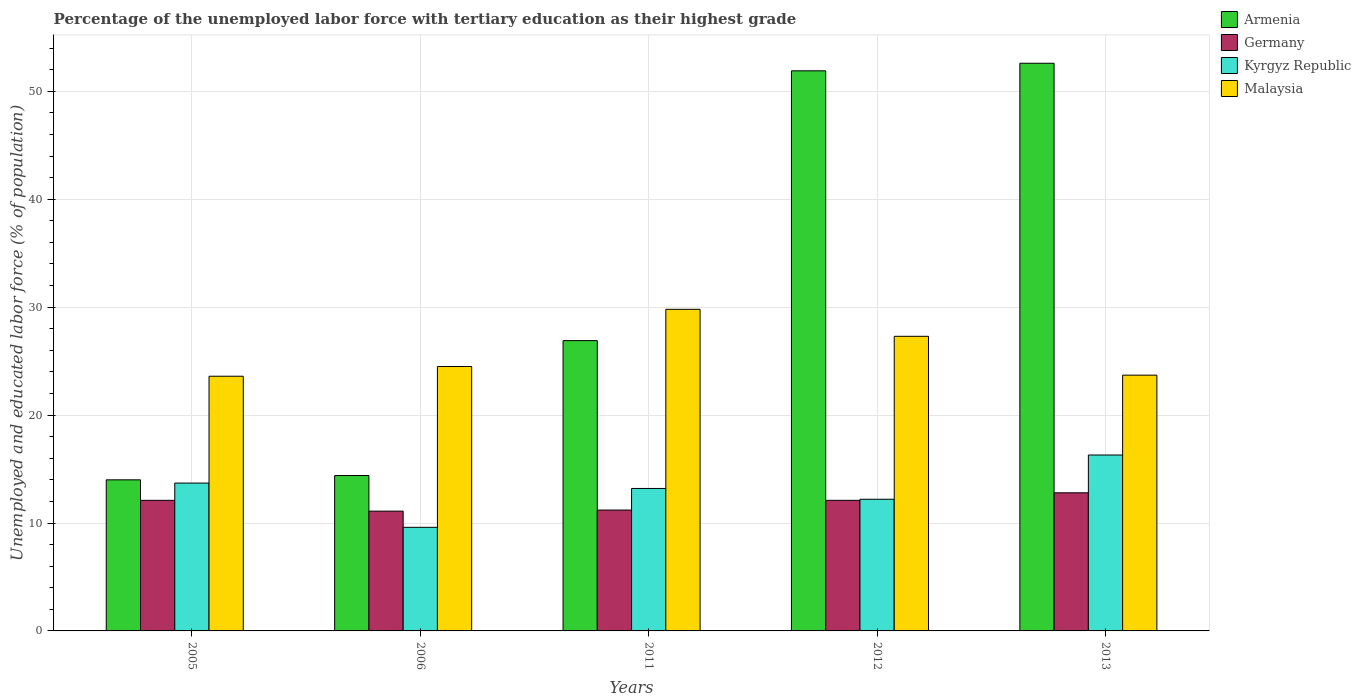How many different coloured bars are there?
Offer a terse response. 4. How many bars are there on the 4th tick from the left?
Offer a very short reply. 4. In how many cases, is the number of bars for a given year not equal to the number of legend labels?
Make the answer very short. 0. What is the percentage of the unemployed labor force with tertiary education in Malaysia in 2005?
Your answer should be very brief. 23.6. Across all years, what is the maximum percentage of the unemployed labor force with tertiary education in Armenia?
Your answer should be very brief. 52.6. Across all years, what is the minimum percentage of the unemployed labor force with tertiary education in Armenia?
Give a very brief answer. 14. In which year was the percentage of the unemployed labor force with tertiary education in Malaysia minimum?
Your answer should be very brief. 2005. What is the total percentage of the unemployed labor force with tertiary education in Malaysia in the graph?
Provide a succinct answer. 128.9. What is the difference between the percentage of the unemployed labor force with tertiary education in Armenia in 2011 and that in 2012?
Your response must be concise. -25. What is the difference between the percentage of the unemployed labor force with tertiary education in Germany in 2012 and the percentage of the unemployed labor force with tertiary education in Armenia in 2013?
Give a very brief answer. -40.5. What is the average percentage of the unemployed labor force with tertiary education in Germany per year?
Your answer should be very brief. 11.86. In the year 2011, what is the difference between the percentage of the unemployed labor force with tertiary education in Kyrgyz Republic and percentage of the unemployed labor force with tertiary education in Germany?
Your answer should be compact. 2. In how many years, is the percentage of the unemployed labor force with tertiary education in Kyrgyz Republic greater than 38 %?
Your answer should be compact. 0. What is the ratio of the percentage of the unemployed labor force with tertiary education in Kyrgyz Republic in 2005 to that in 2011?
Keep it short and to the point. 1.04. Is the percentage of the unemployed labor force with tertiary education in Armenia in 2012 less than that in 2013?
Your response must be concise. Yes. Is the difference between the percentage of the unemployed labor force with tertiary education in Kyrgyz Republic in 2006 and 2011 greater than the difference between the percentage of the unemployed labor force with tertiary education in Germany in 2006 and 2011?
Your response must be concise. No. What is the difference between the highest and the lowest percentage of the unemployed labor force with tertiary education in Malaysia?
Your answer should be very brief. 6.2. In how many years, is the percentage of the unemployed labor force with tertiary education in Germany greater than the average percentage of the unemployed labor force with tertiary education in Germany taken over all years?
Make the answer very short. 3. Is the sum of the percentage of the unemployed labor force with tertiary education in Kyrgyz Republic in 2011 and 2012 greater than the maximum percentage of the unemployed labor force with tertiary education in Armenia across all years?
Offer a terse response. No. Is it the case that in every year, the sum of the percentage of the unemployed labor force with tertiary education in Kyrgyz Republic and percentage of the unemployed labor force with tertiary education in Germany is greater than the sum of percentage of the unemployed labor force with tertiary education in Malaysia and percentage of the unemployed labor force with tertiary education in Armenia?
Offer a very short reply. No. What does the 2nd bar from the right in 2006 represents?
Ensure brevity in your answer.  Kyrgyz Republic. Is it the case that in every year, the sum of the percentage of the unemployed labor force with tertiary education in Kyrgyz Republic and percentage of the unemployed labor force with tertiary education in Germany is greater than the percentage of the unemployed labor force with tertiary education in Malaysia?
Give a very brief answer. No. How many bars are there?
Your answer should be very brief. 20. Are all the bars in the graph horizontal?
Your answer should be very brief. No. How many years are there in the graph?
Provide a succinct answer. 5. What is the difference between two consecutive major ticks on the Y-axis?
Your answer should be very brief. 10. Does the graph contain grids?
Provide a succinct answer. Yes. How many legend labels are there?
Your answer should be compact. 4. How are the legend labels stacked?
Offer a very short reply. Vertical. What is the title of the graph?
Offer a very short reply. Percentage of the unemployed labor force with tertiary education as their highest grade. What is the label or title of the X-axis?
Provide a short and direct response. Years. What is the label or title of the Y-axis?
Provide a succinct answer. Unemployed and educated labor force (% of population). What is the Unemployed and educated labor force (% of population) in Armenia in 2005?
Your answer should be compact. 14. What is the Unemployed and educated labor force (% of population) in Germany in 2005?
Offer a very short reply. 12.1. What is the Unemployed and educated labor force (% of population) in Kyrgyz Republic in 2005?
Provide a short and direct response. 13.7. What is the Unemployed and educated labor force (% of population) of Malaysia in 2005?
Keep it short and to the point. 23.6. What is the Unemployed and educated labor force (% of population) of Armenia in 2006?
Your response must be concise. 14.4. What is the Unemployed and educated labor force (% of population) of Germany in 2006?
Provide a short and direct response. 11.1. What is the Unemployed and educated labor force (% of population) in Kyrgyz Republic in 2006?
Keep it short and to the point. 9.6. What is the Unemployed and educated labor force (% of population) of Malaysia in 2006?
Your answer should be very brief. 24.5. What is the Unemployed and educated labor force (% of population) in Armenia in 2011?
Your answer should be compact. 26.9. What is the Unemployed and educated labor force (% of population) in Germany in 2011?
Keep it short and to the point. 11.2. What is the Unemployed and educated labor force (% of population) of Kyrgyz Republic in 2011?
Offer a terse response. 13.2. What is the Unemployed and educated labor force (% of population) in Malaysia in 2011?
Provide a short and direct response. 29.8. What is the Unemployed and educated labor force (% of population) in Armenia in 2012?
Your response must be concise. 51.9. What is the Unemployed and educated labor force (% of population) in Germany in 2012?
Offer a terse response. 12.1. What is the Unemployed and educated labor force (% of population) of Kyrgyz Republic in 2012?
Your answer should be very brief. 12.2. What is the Unemployed and educated labor force (% of population) of Malaysia in 2012?
Offer a very short reply. 27.3. What is the Unemployed and educated labor force (% of population) in Armenia in 2013?
Your answer should be compact. 52.6. What is the Unemployed and educated labor force (% of population) in Germany in 2013?
Your response must be concise. 12.8. What is the Unemployed and educated labor force (% of population) of Kyrgyz Republic in 2013?
Keep it short and to the point. 16.3. What is the Unemployed and educated labor force (% of population) in Malaysia in 2013?
Your response must be concise. 23.7. Across all years, what is the maximum Unemployed and educated labor force (% of population) in Armenia?
Provide a short and direct response. 52.6. Across all years, what is the maximum Unemployed and educated labor force (% of population) in Germany?
Give a very brief answer. 12.8. Across all years, what is the maximum Unemployed and educated labor force (% of population) of Kyrgyz Republic?
Offer a terse response. 16.3. Across all years, what is the maximum Unemployed and educated labor force (% of population) of Malaysia?
Make the answer very short. 29.8. Across all years, what is the minimum Unemployed and educated labor force (% of population) in Armenia?
Provide a short and direct response. 14. Across all years, what is the minimum Unemployed and educated labor force (% of population) in Germany?
Your answer should be compact. 11.1. Across all years, what is the minimum Unemployed and educated labor force (% of population) in Kyrgyz Republic?
Your answer should be compact. 9.6. Across all years, what is the minimum Unemployed and educated labor force (% of population) of Malaysia?
Provide a short and direct response. 23.6. What is the total Unemployed and educated labor force (% of population) in Armenia in the graph?
Give a very brief answer. 159.8. What is the total Unemployed and educated labor force (% of population) in Germany in the graph?
Give a very brief answer. 59.3. What is the total Unemployed and educated labor force (% of population) in Kyrgyz Republic in the graph?
Give a very brief answer. 65. What is the total Unemployed and educated labor force (% of population) of Malaysia in the graph?
Provide a short and direct response. 128.9. What is the difference between the Unemployed and educated labor force (% of population) of Armenia in 2005 and that in 2006?
Give a very brief answer. -0.4. What is the difference between the Unemployed and educated labor force (% of population) in Malaysia in 2005 and that in 2006?
Make the answer very short. -0.9. What is the difference between the Unemployed and educated labor force (% of population) of Germany in 2005 and that in 2011?
Give a very brief answer. 0.9. What is the difference between the Unemployed and educated labor force (% of population) of Kyrgyz Republic in 2005 and that in 2011?
Provide a short and direct response. 0.5. What is the difference between the Unemployed and educated labor force (% of population) in Malaysia in 2005 and that in 2011?
Offer a terse response. -6.2. What is the difference between the Unemployed and educated labor force (% of population) in Armenia in 2005 and that in 2012?
Make the answer very short. -37.9. What is the difference between the Unemployed and educated labor force (% of population) in Armenia in 2005 and that in 2013?
Give a very brief answer. -38.6. What is the difference between the Unemployed and educated labor force (% of population) of Kyrgyz Republic in 2005 and that in 2013?
Offer a terse response. -2.6. What is the difference between the Unemployed and educated labor force (% of population) in Germany in 2006 and that in 2011?
Ensure brevity in your answer.  -0.1. What is the difference between the Unemployed and educated labor force (% of population) in Armenia in 2006 and that in 2012?
Offer a terse response. -37.5. What is the difference between the Unemployed and educated labor force (% of population) in Germany in 2006 and that in 2012?
Ensure brevity in your answer.  -1. What is the difference between the Unemployed and educated labor force (% of population) of Kyrgyz Republic in 2006 and that in 2012?
Give a very brief answer. -2.6. What is the difference between the Unemployed and educated labor force (% of population) of Armenia in 2006 and that in 2013?
Ensure brevity in your answer.  -38.2. What is the difference between the Unemployed and educated labor force (% of population) in Kyrgyz Republic in 2006 and that in 2013?
Your answer should be very brief. -6.7. What is the difference between the Unemployed and educated labor force (% of population) in Malaysia in 2006 and that in 2013?
Your answer should be very brief. 0.8. What is the difference between the Unemployed and educated labor force (% of population) of Germany in 2011 and that in 2012?
Ensure brevity in your answer.  -0.9. What is the difference between the Unemployed and educated labor force (% of population) in Malaysia in 2011 and that in 2012?
Your answer should be compact. 2.5. What is the difference between the Unemployed and educated labor force (% of population) of Armenia in 2011 and that in 2013?
Your answer should be very brief. -25.7. What is the difference between the Unemployed and educated labor force (% of population) in Germany in 2011 and that in 2013?
Your answer should be compact. -1.6. What is the difference between the Unemployed and educated labor force (% of population) in Kyrgyz Republic in 2011 and that in 2013?
Your response must be concise. -3.1. What is the difference between the Unemployed and educated labor force (% of population) of Malaysia in 2011 and that in 2013?
Ensure brevity in your answer.  6.1. What is the difference between the Unemployed and educated labor force (% of population) in Armenia in 2012 and that in 2013?
Offer a terse response. -0.7. What is the difference between the Unemployed and educated labor force (% of population) in Germany in 2012 and that in 2013?
Your response must be concise. -0.7. What is the difference between the Unemployed and educated labor force (% of population) of Kyrgyz Republic in 2012 and that in 2013?
Make the answer very short. -4.1. What is the difference between the Unemployed and educated labor force (% of population) in Armenia in 2005 and the Unemployed and educated labor force (% of population) in Kyrgyz Republic in 2006?
Keep it short and to the point. 4.4. What is the difference between the Unemployed and educated labor force (% of population) of Armenia in 2005 and the Unemployed and educated labor force (% of population) of Malaysia in 2006?
Your answer should be very brief. -10.5. What is the difference between the Unemployed and educated labor force (% of population) in Germany in 2005 and the Unemployed and educated labor force (% of population) in Malaysia in 2006?
Provide a succinct answer. -12.4. What is the difference between the Unemployed and educated labor force (% of population) of Kyrgyz Republic in 2005 and the Unemployed and educated labor force (% of population) of Malaysia in 2006?
Provide a short and direct response. -10.8. What is the difference between the Unemployed and educated labor force (% of population) of Armenia in 2005 and the Unemployed and educated labor force (% of population) of Malaysia in 2011?
Make the answer very short. -15.8. What is the difference between the Unemployed and educated labor force (% of population) of Germany in 2005 and the Unemployed and educated labor force (% of population) of Malaysia in 2011?
Offer a terse response. -17.7. What is the difference between the Unemployed and educated labor force (% of population) of Kyrgyz Republic in 2005 and the Unemployed and educated labor force (% of population) of Malaysia in 2011?
Make the answer very short. -16.1. What is the difference between the Unemployed and educated labor force (% of population) in Armenia in 2005 and the Unemployed and educated labor force (% of population) in Germany in 2012?
Keep it short and to the point. 1.9. What is the difference between the Unemployed and educated labor force (% of population) of Armenia in 2005 and the Unemployed and educated labor force (% of population) of Kyrgyz Republic in 2012?
Your answer should be compact. 1.8. What is the difference between the Unemployed and educated labor force (% of population) of Armenia in 2005 and the Unemployed and educated labor force (% of population) of Malaysia in 2012?
Provide a succinct answer. -13.3. What is the difference between the Unemployed and educated labor force (% of population) in Germany in 2005 and the Unemployed and educated labor force (% of population) in Kyrgyz Republic in 2012?
Keep it short and to the point. -0.1. What is the difference between the Unemployed and educated labor force (% of population) in Germany in 2005 and the Unemployed and educated labor force (% of population) in Malaysia in 2012?
Offer a terse response. -15.2. What is the difference between the Unemployed and educated labor force (% of population) of Armenia in 2005 and the Unemployed and educated labor force (% of population) of Germany in 2013?
Your response must be concise. 1.2. What is the difference between the Unemployed and educated labor force (% of population) of Armenia in 2005 and the Unemployed and educated labor force (% of population) of Kyrgyz Republic in 2013?
Provide a succinct answer. -2.3. What is the difference between the Unemployed and educated labor force (% of population) of Armenia in 2005 and the Unemployed and educated labor force (% of population) of Malaysia in 2013?
Keep it short and to the point. -9.7. What is the difference between the Unemployed and educated labor force (% of population) in Armenia in 2006 and the Unemployed and educated labor force (% of population) in Germany in 2011?
Offer a very short reply. 3.2. What is the difference between the Unemployed and educated labor force (% of population) in Armenia in 2006 and the Unemployed and educated labor force (% of population) in Malaysia in 2011?
Your answer should be very brief. -15.4. What is the difference between the Unemployed and educated labor force (% of population) of Germany in 2006 and the Unemployed and educated labor force (% of population) of Kyrgyz Republic in 2011?
Your answer should be compact. -2.1. What is the difference between the Unemployed and educated labor force (% of population) in Germany in 2006 and the Unemployed and educated labor force (% of population) in Malaysia in 2011?
Ensure brevity in your answer.  -18.7. What is the difference between the Unemployed and educated labor force (% of population) of Kyrgyz Republic in 2006 and the Unemployed and educated labor force (% of population) of Malaysia in 2011?
Keep it short and to the point. -20.2. What is the difference between the Unemployed and educated labor force (% of population) of Germany in 2006 and the Unemployed and educated labor force (% of population) of Kyrgyz Republic in 2012?
Keep it short and to the point. -1.1. What is the difference between the Unemployed and educated labor force (% of population) of Germany in 2006 and the Unemployed and educated labor force (% of population) of Malaysia in 2012?
Provide a succinct answer. -16.2. What is the difference between the Unemployed and educated labor force (% of population) of Kyrgyz Republic in 2006 and the Unemployed and educated labor force (% of population) of Malaysia in 2012?
Ensure brevity in your answer.  -17.7. What is the difference between the Unemployed and educated labor force (% of population) in Armenia in 2006 and the Unemployed and educated labor force (% of population) in Kyrgyz Republic in 2013?
Offer a very short reply. -1.9. What is the difference between the Unemployed and educated labor force (% of population) of Armenia in 2006 and the Unemployed and educated labor force (% of population) of Malaysia in 2013?
Offer a terse response. -9.3. What is the difference between the Unemployed and educated labor force (% of population) of Germany in 2006 and the Unemployed and educated labor force (% of population) of Kyrgyz Republic in 2013?
Give a very brief answer. -5.2. What is the difference between the Unemployed and educated labor force (% of population) in Kyrgyz Republic in 2006 and the Unemployed and educated labor force (% of population) in Malaysia in 2013?
Provide a succinct answer. -14.1. What is the difference between the Unemployed and educated labor force (% of population) in Armenia in 2011 and the Unemployed and educated labor force (% of population) in Germany in 2012?
Your response must be concise. 14.8. What is the difference between the Unemployed and educated labor force (% of population) of Germany in 2011 and the Unemployed and educated labor force (% of population) of Malaysia in 2012?
Make the answer very short. -16.1. What is the difference between the Unemployed and educated labor force (% of population) in Kyrgyz Republic in 2011 and the Unemployed and educated labor force (% of population) in Malaysia in 2012?
Give a very brief answer. -14.1. What is the difference between the Unemployed and educated labor force (% of population) in Armenia in 2011 and the Unemployed and educated labor force (% of population) in Germany in 2013?
Keep it short and to the point. 14.1. What is the difference between the Unemployed and educated labor force (% of population) in Armenia in 2011 and the Unemployed and educated labor force (% of population) in Kyrgyz Republic in 2013?
Provide a succinct answer. 10.6. What is the difference between the Unemployed and educated labor force (% of population) in Armenia in 2011 and the Unemployed and educated labor force (% of population) in Malaysia in 2013?
Offer a terse response. 3.2. What is the difference between the Unemployed and educated labor force (% of population) of Germany in 2011 and the Unemployed and educated labor force (% of population) of Kyrgyz Republic in 2013?
Your answer should be very brief. -5.1. What is the difference between the Unemployed and educated labor force (% of population) in Germany in 2011 and the Unemployed and educated labor force (% of population) in Malaysia in 2013?
Your response must be concise. -12.5. What is the difference between the Unemployed and educated labor force (% of population) of Armenia in 2012 and the Unemployed and educated labor force (% of population) of Germany in 2013?
Ensure brevity in your answer.  39.1. What is the difference between the Unemployed and educated labor force (% of population) of Armenia in 2012 and the Unemployed and educated labor force (% of population) of Kyrgyz Republic in 2013?
Keep it short and to the point. 35.6. What is the difference between the Unemployed and educated labor force (% of population) of Armenia in 2012 and the Unemployed and educated labor force (% of population) of Malaysia in 2013?
Provide a succinct answer. 28.2. What is the average Unemployed and educated labor force (% of population) in Armenia per year?
Keep it short and to the point. 31.96. What is the average Unemployed and educated labor force (% of population) in Germany per year?
Your response must be concise. 11.86. What is the average Unemployed and educated labor force (% of population) in Kyrgyz Republic per year?
Offer a terse response. 13. What is the average Unemployed and educated labor force (% of population) of Malaysia per year?
Your answer should be very brief. 25.78. In the year 2005, what is the difference between the Unemployed and educated labor force (% of population) in Armenia and Unemployed and educated labor force (% of population) in Germany?
Make the answer very short. 1.9. In the year 2005, what is the difference between the Unemployed and educated labor force (% of population) in Armenia and Unemployed and educated labor force (% of population) in Malaysia?
Offer a very short reply. -9.6. In the year 2005, what is the difference between the Unemployed and educated labor force (% of population) in Germany and Unemployed and educated labor force (% of population) in Kyrgyz Republic?
Your response must be concise. -1.6. In the year 2005, what is the difference between the Unemployed and educated labor force (% of population) of Germany and Unemployed and educated labor force (% of population) of Malaysia?
Provide a succinct answer. -11.5. In the year 2005, what is the difference between the Unemployed and educated labor force (% of population) of Kyrgyz Republic and Unemployed and educated labor force (% of population) of Malaysia?
Your answer should be compact. -9.9. In the year 2006, what is the difference between the Unemployed and educated labor force (% of population) of Armenia and Unemployed and educated labor force (% of population) of Germany?
Keep it short and to the point. 3.3. In the year 2006, what is the difference between the Unemployed and educated labor force (% of population) in Germany and Unemployed and educated labor force (% of population) in Kyrgyz Republic?
Offer a very short reply. 1.5. In the year 2006, what is the difference between the Unemployed and educated labor force (% of population) of Germany and Unemployed and educated labor force (% of population) of Malaysia?
Offer a terse response. -13.4. In the year 2006, what is the difference between the Unemployed and educated labor force (% of population) of Kyrgyz Republic and Unemployed and educated labor force (% of population) of Malaysia?
Provide a short and direct response. -14.9. In the year 2011, what is the difference between the Unemployed and educated labor force (% of population) in Germany and Unemployed and educated labor force (% of population) in Malaysia?
Give a very brief answer. -18.6. In the year 2011, what is the difference between the Unemployed and educated labor force (% of population) of Kyrgyz Republic and Unemployed and educated labor force (% of population) of Malaysia?
Your response must be concise. -16.6. In the year 2012, what is the difference between the Unemployed and educated labor force (% of population) of Armenia and Unemployed and educated labor force (% of population) of Germany?
Ensure brevity in your answer.  39.8. In the year 2012, what is the difference between the Unemployed and educated labor force (% of population) of Armenia and Unemployed and educated labor force (% of population) of Kyrgyz Republic?
Provide a short and direct response. 39.7. In the year 2012, what is the difference between the Unemployed and educated labor force (% of population) in Armenia and Unemployed and educated labor force (% of population) in Malaysia?
Make the answer very short. 24.6. In the year 2012, what is the difference between the Unemployed and educated labor force (% of population) of Germany and Unemployed and educated labor force (% of population) of Malaysia?
Offer a terse response. -15.2. In the year 2012, what is the difference between the Unemployed and educated labor force (% of population) of Kyrgyz Republic and Unemployed and educated labor force (% of population) of Malaysia?
Keep it short and to the point. -15.1. In the year 2013, what is the difference between the Unemployed and educated labor force (% of population) in Armenia and Unemployed and educated labor force (% of population) in Germany?
Keep it short and to the point. 39.8. In the year 2013, what is the difference between the Unemployed and educated labor force (% of population) of Armenia and Unemployed and educated labor force (% of population) of Kyrgyz Republic?
Your response must be concise. 36.3. In the year 2013, what is the difference between the Unemployed and educated labor force (% of population) of Armenia and Unemployed and educated labor force (% of population) of Malaysia?
Give a very brief answer. 28.9. In the year 2013, what is the difference between the Unemployed and educated labor force (% of population) of Germany and Unemployed and educated labor force (% of population) of Malaysia?
Provide a short and direct response. -10.9. What is the ratio of the Unemployed and educated labor force (% of population) in Armenia in 2005 to that in 2006?
Offer a very short reply. 0.97. What is the ratio of the Unemployed and educated labor force (% of population) in Germany in 2005 to that in 2006?
Offer a terse response. 1.09. What is the ratio of the Unemployed and educated labor force (% of population) of Kyrgyz Republic in 2005 to that in 2006?
Provide a short and direct response. 1.43. What is the ratio of the Unemployed and educated labor force (% of population) of Malaysia in 2005 to that in 2006?
Ensure brevity in your answer.  0.96. What is the ratio of the Unemployed and educated labor force (% of population) in Armenia in 2005 to that in 2011?
Provide a succinct answer. 0.52. What is the ratio of the Unemployed and educated labor force (% of population) in Germany in 2005 to that in 2011?
Give a very brief answer. 1.08. What is the ratio of the Unemployed and educated labor force (% of population) of Kyrgyz Republic in 2005 to that in 2011?
Provide a short and direct response. 1.04. What is the ratio of the Unemployed and educated labor force (% of population) of Malaysia in 2005 to that in 2011?
Provide a succinct answer. 0.79. What is the ratio of the Unemployed and educated labor force (% of population) of Armenia in 2005 to that in 2012?
Keep it short and to the point. 0.27. What is the ratio of the Unemployed and educated labor force (% of population) in Kyrgyz Republic in 2005 to that in 2012?
Your answer should be compact. 1.12. What is the ratio of the Unemployed and educated labor force (% of population) of Malaysia in 2005 to that in 2012?
Ensure brevity in your answer.  0.86. What is the ratio of the Unemployed and educated labor force (% of population) of Armenia in 2005 to that in 2013?
Keep it short and to the point. 0.27. What is the ratio of the Unemployed and educated labor force (% of population) in Germany in 2005 to that in 2013?
Ensure brevity in your answer.  0.95. What is the ratio of the Unemployed and educated labor force (% of population) in Kyrgyz Republic in 2005 to that in 2013?
Your answer should be compact. 0.84. What is the ratio of the Unemployed and educated labor force (% of population) in Armenia in 2006 to that in 2011?
Your response must be concise. 0.54. What is the ratio of the Unemployed and educated labor force (% of population) of Germany in 2006 to that in 2011?
Your response must be concise. 0.99. What is the ratio of the Unemployed and educated labor force (% of population) in Kyrgyz Republic in 2006 to that in 2011?
Your answer should be very brief. 0.73. What is the ratio of the Unemployed and educated labor force (% of population) in Malaysia in 2006 to that in 2011?
Make the answer very short. 0.82. What is the ratio of the Unemployed and educated labor force (% of population) of Armenia in 2006 to that in 2012?
Your answer should be very brief. 0.28. What is the ratio of the Unemployed and educated labor force (% of population) in Germany in 2006 to that in 2012?
Give a very brief answer. 0.92. What is the ratio of the Unemployed and educated labor force (% of population) in Kyrgyz Republic in 2006 to that in 2012?
Ensure brevity in your answer.  0.79. What is the ratio of the Unemployed and educated labor force (% of population) in Malaysia in 2006 to that in 2012?
Ensure brevity in your answer.  0.9. What is the ratio of the Unemployed and educated labor force (% of population) of Armenia in 2006 to that in 2013?
Provide a short and direct response. 0.27. What is the ratio of the Unemployed and educated labor force (% of population) in Germany in 2006 to that in 2013?
Your answer should be very brief. 0.87. What is the ratio of the Unemployed and educated labor force (% of population) in Kyrgyz Republic in 2006 to that in 2013?
Your answer should be compact. 0.59. What is the ratio of the Unemployed and educated labor force (% of population) in Malaysia in 2006 to that in 2013?
Ensure brevity in your answer.  1.03. What is the ratio of the Unemployed and educated labor force (% of population) of Armenia in 2011 to that in 2012?
Offer a terse response. 0.52. What is the ratio of the Unemployed and educated labor force (% of population) of Germany in 2011 to that in 2012?
Provide a succinct answer. 0.93. What is the ratio of the Unemployed and educated labor force (% of population) in Kyrgyz Republic in 2011 to that in 2012?
Ensure brevity in your answer.  1.08. What is the ratio of the Unemployed and educated labor force (% of population) in Malaysia in 2011 to that in 2012?
Give a very brief answer. 1.09. What is the ratio of the Unemployed and educated labor force (% of population) of Armenia in 2011 to that in 2013?
Your answer should be compact. 0.51. What is the ratio of the Unemployed and educated labor force (% of population) in Kyrgyz Republic in 2011 to that in 2013?
Offer a terse response. 0.81. What is the ratio of the Unemployed and educated labor force (% of population) in Malaysia in 2011 to that in 2013?
Your answer should be very brief. 1.26. What is the ratio of the Unemployed and educated labor force (% of population) of Armenia in 2012 to that in 2013?
Provide a short and direct response. 0.99. What is the ratio of the Unemployed and educated labor force (% of population) of Germany in 2012 to that in 2013?
Offer a terse response. 0.95. What is the ratio of the Unemployed and educated labor force (% of population) in Kyrgyz Republic in 2012 to that in 2013?
Make the answer very short. 0.75. What is the ratio of the Unemployed and educated labor force (% of population) in Malaysia in 2012 to that in 2013?
Your answer should be very brief. 1.15. What is the difference between the highest and the second highest Unemployed and educated labor force (% of population) of Armenia?
Offer a terse response. 0.7. What is the difference between the highest and the second highest Unemployed and educated labor force (% of population) in Germany?
Provide a short and direct response. 0.7. What is the difference between the highest and the second highest Unemployed and educated labor force (% of population) in Malaysia?
Your answer should be compact. 2.5. What is the difference between the highest and the lowest Unemployed and educated labor force (% of population) in Armenia?
Make the answer very short. 38.6. What is the difference between the highest and the lowest Unemployed and educated labor force (% of population) in Malaysia?
Your response must be concise. 6.2. 